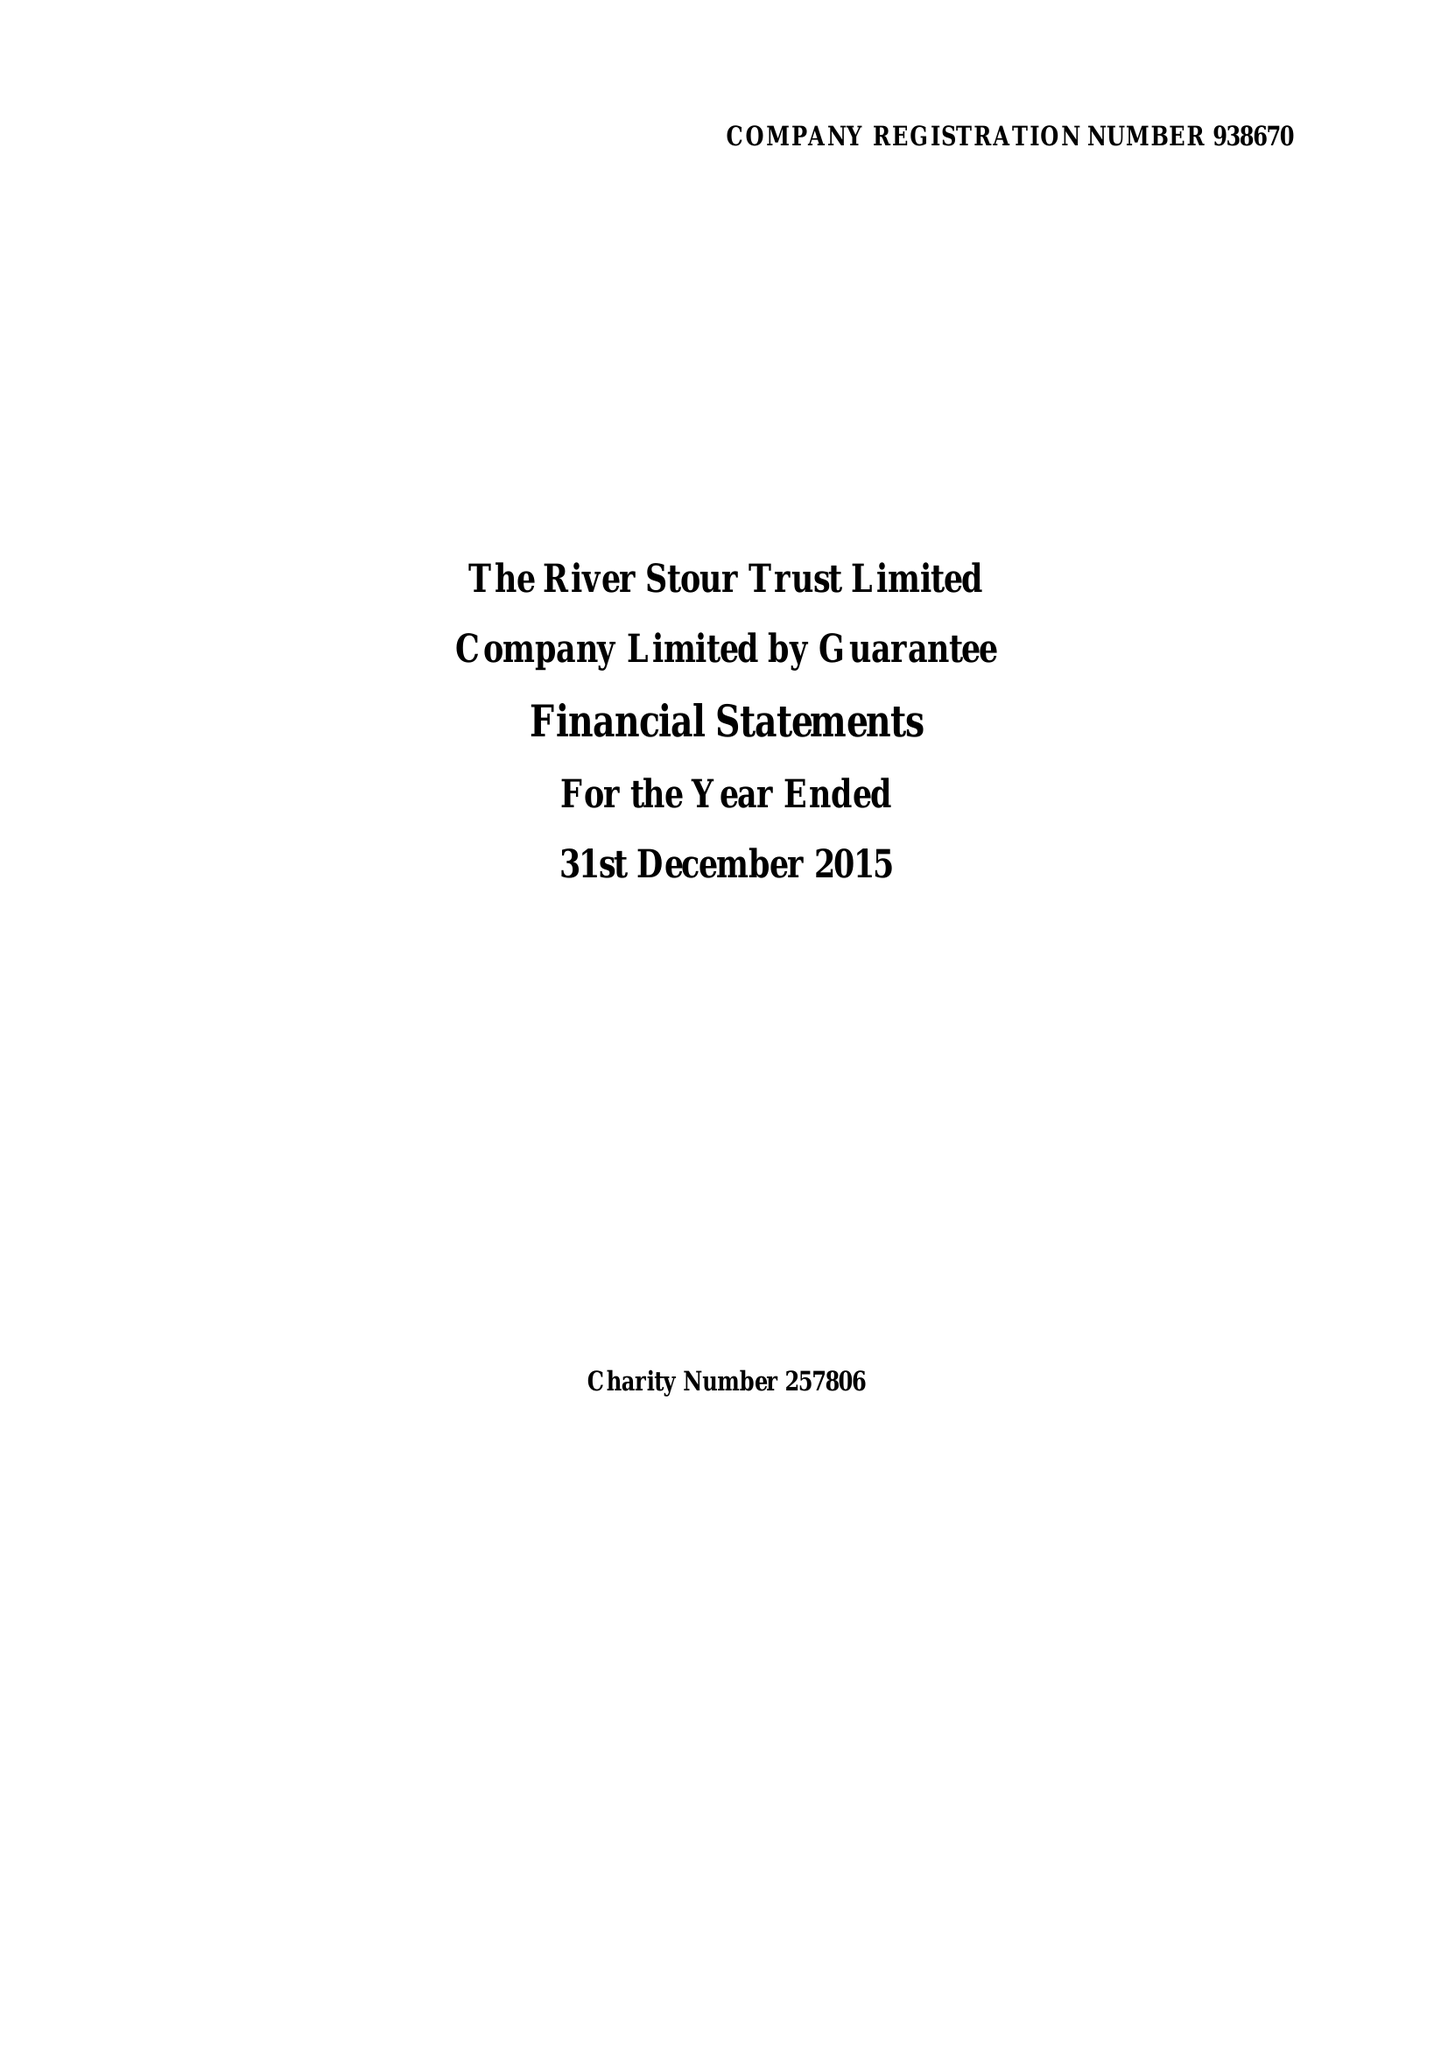What is the value for the charity_name?
Answer the question using a single word or phrase. The River Stour Trust Ltd. 